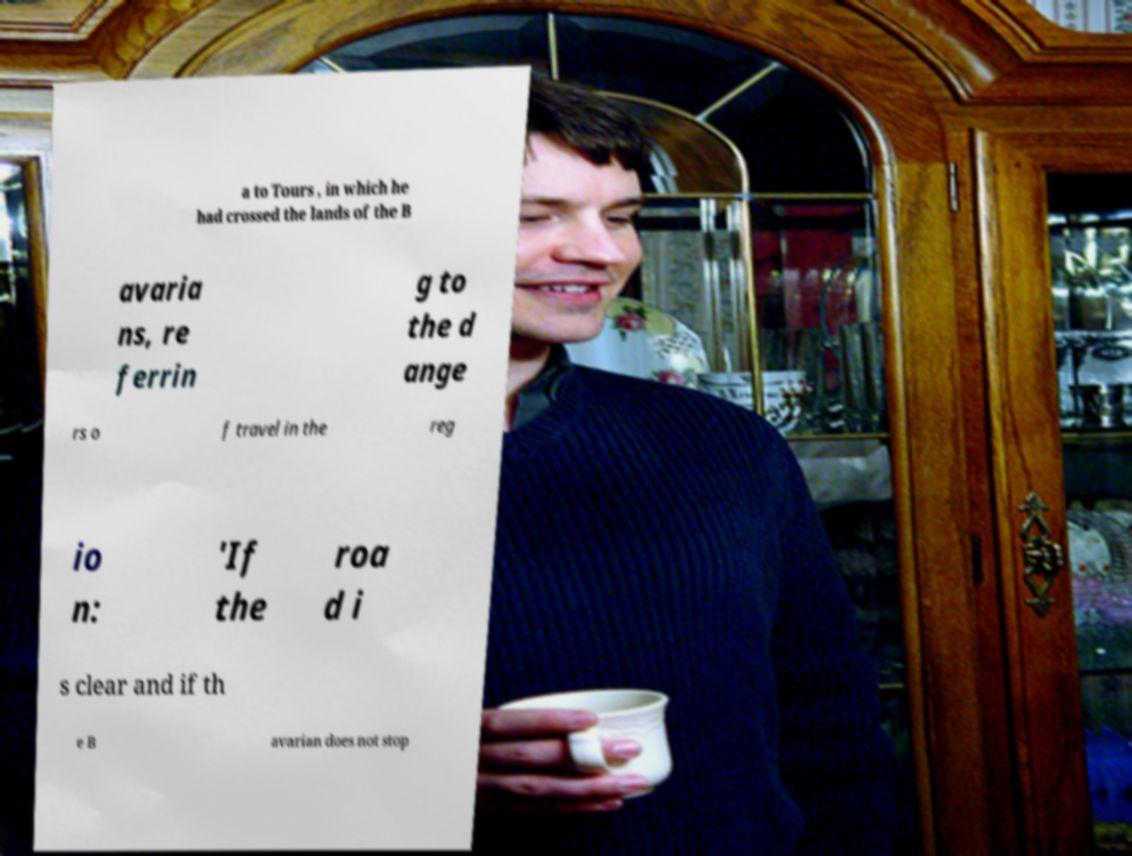What messages or text are displayed in this image? I need them in a readable, typed format. a to Tours , in which he had crossed the lands of the B avaria ns, re ferrin g to the d ange rs o f travel in the reg io n: 'If the roa d i s clear and if th e B avarian does not stop 